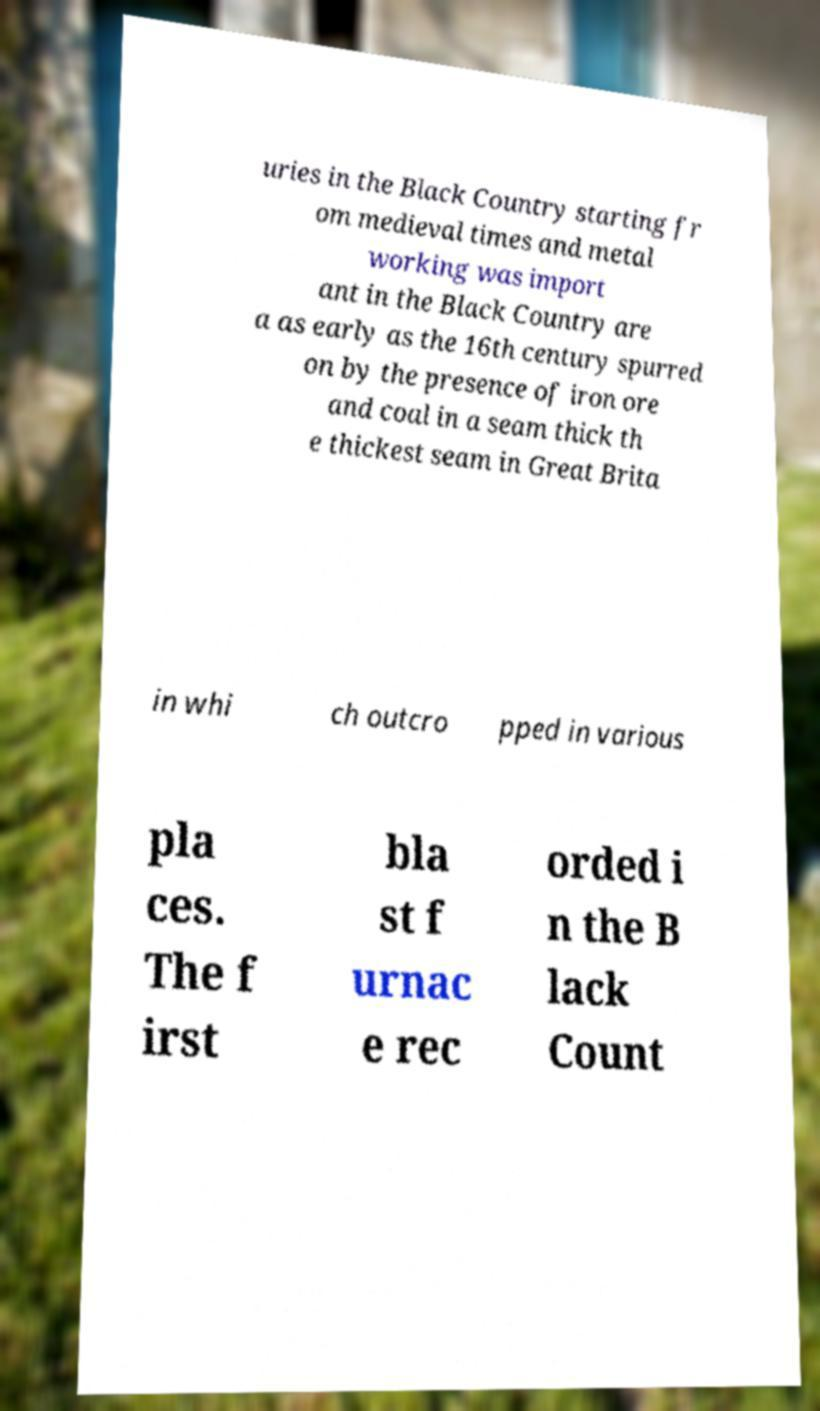What messages or text are displayed in this image? I need them in a readable, typed format. uries in the Black Country starting fr om medieval times and metal working was import ant in the Black Country are a as early as the 16th century spurred on by the presence of iron ore and coal in a seam thick th e thickest seam in Great Brita in whi ch outcro pped in various pla ces. The f irst bla st f urnac e rec orded i n the B lack Count 